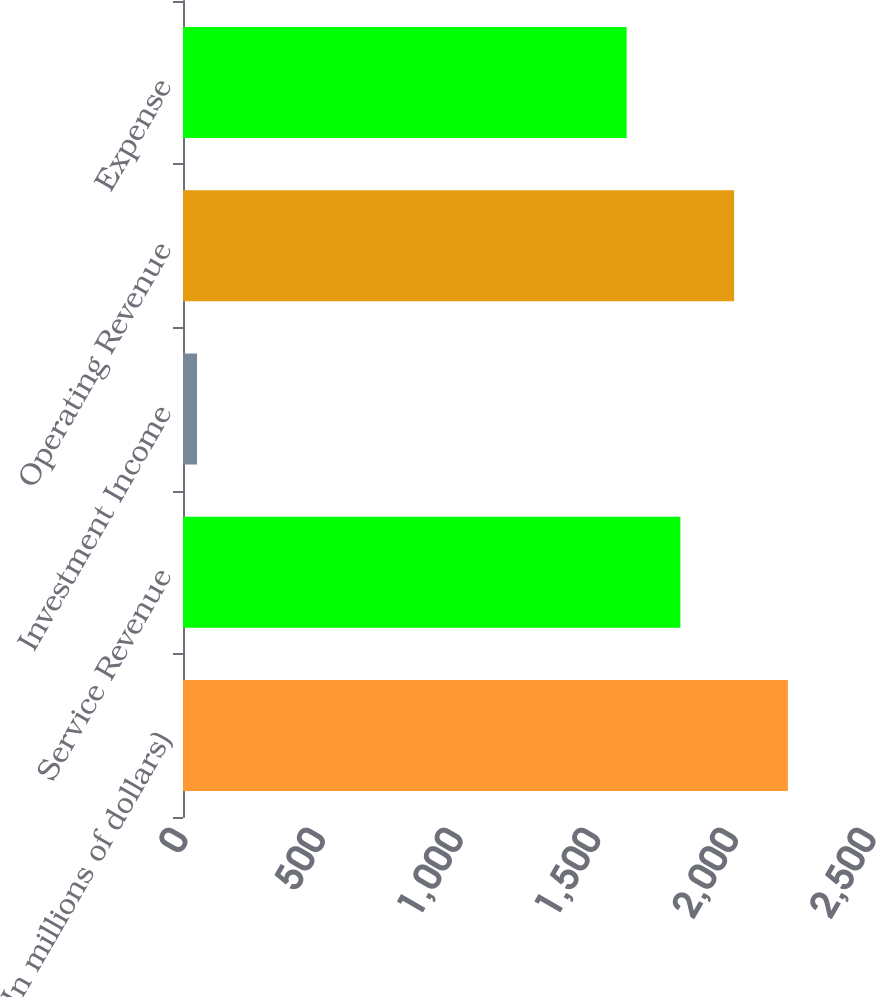<chart> <loc_0><loc_0><loc_500><loc_500><bar_chart><fcel>(In millions of dollars)<fcel>Service Revenue<fcel>Investment Income<fcel>Operating Revenue<fcel>Expense<nl><fcel>2197.9<fcel>1807.3<fcel>51<fcel>2002.6<fcel>1612<nl></chart> 